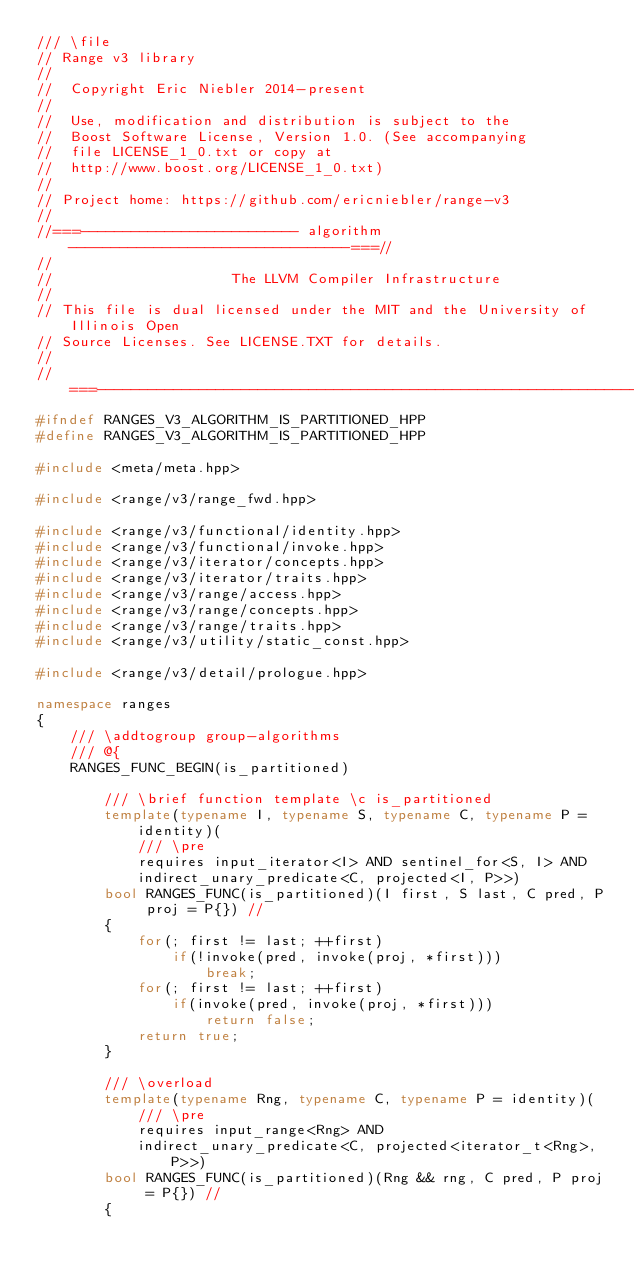Convert code to text. <code><loc_0><loc_0><loc_500><loc_500><_C++_>/// \file
// Range v3 library
//
//  Copyright Eric Niebler 2014-present
//
//  Use, modification and distribution is subject to the
//  Boost Software License, Version 1.0. (See accompanying
//  file LICENSE_1_0.txt or copy at
//  http://www.boost.org/LICENSE_1_0.txt)
//
// Project home: https://github.com/ericniebler/range-v3
//
//===-------------------------- algorithm ---------------------------------===//
//
//                     The LLVM Compiler Infrastructure
//
// This file is dual licensed under the MIT and the University of Illinois Open
// Source Licenses. See LICENSE.TXT for details.
//
//===----------------------------------------------------------------------===//
#ifndef RANGES_V3_ALGORITHM_IS_PARTITIONED_HPP
#define RANGES_V3_ALGORITHM_IS_PARTITIONED_HPP

#include <meta/meta.hpp>

#include <range/v3/range_fwd.hpp>

#include <range/v3/functional/identity.hpp>
#include <range/v3/functional/invoke.hpp>
#include <range/v3/iterator/concepts.hpp>
#include <range/v3/iterator/traits.hpp>
#include <range/v3/range/access.hpp>
#include <range/v3/range/concepts.hpp>
#include <range/v3/range/traits.hpp>
#include <range/v3/utility/static_const.hpp>

#include <range/v3/detail/prologue.hpp>

namespace ranges
{
    /// \addtogroup group-algorithms
    /// @{
    RANGES_FUNC_BEGIN(is_partitioned)

        /// \brief function template \c is_partitioned
        template(typename I, typename S, typename C, typename P = identity)(
            /// \pre
            requires input_iterator<I> AND sentinel_for<S, I> AND
            indirect_unary_predicate<C, projected<I, P>>)
        bool RANGES_FUNC(is_partitioned)(I first, S last, C pred, P proj = P{}) //
        {
            for(; first != last; ++first)
                if(!invoke(pred, invoke(proj, *first)))
                    break;
            for(; first != last; ++first)
                if(invoke(pred, invoke(proj, *first)))
                    return false;
            return true;
        }

        /// \overload
        template(typename Rng, typename C, typename P = identity)(
            /// \pre
            requires input_range<Rng> AND
            indirect_unary_predicate<C, projected<iterator_t<Rng>, P>>)
        bool RANGES_FUNC(is_partitioned)(Rng && rng, C pred, P proj = P{}) //
        {</code> 